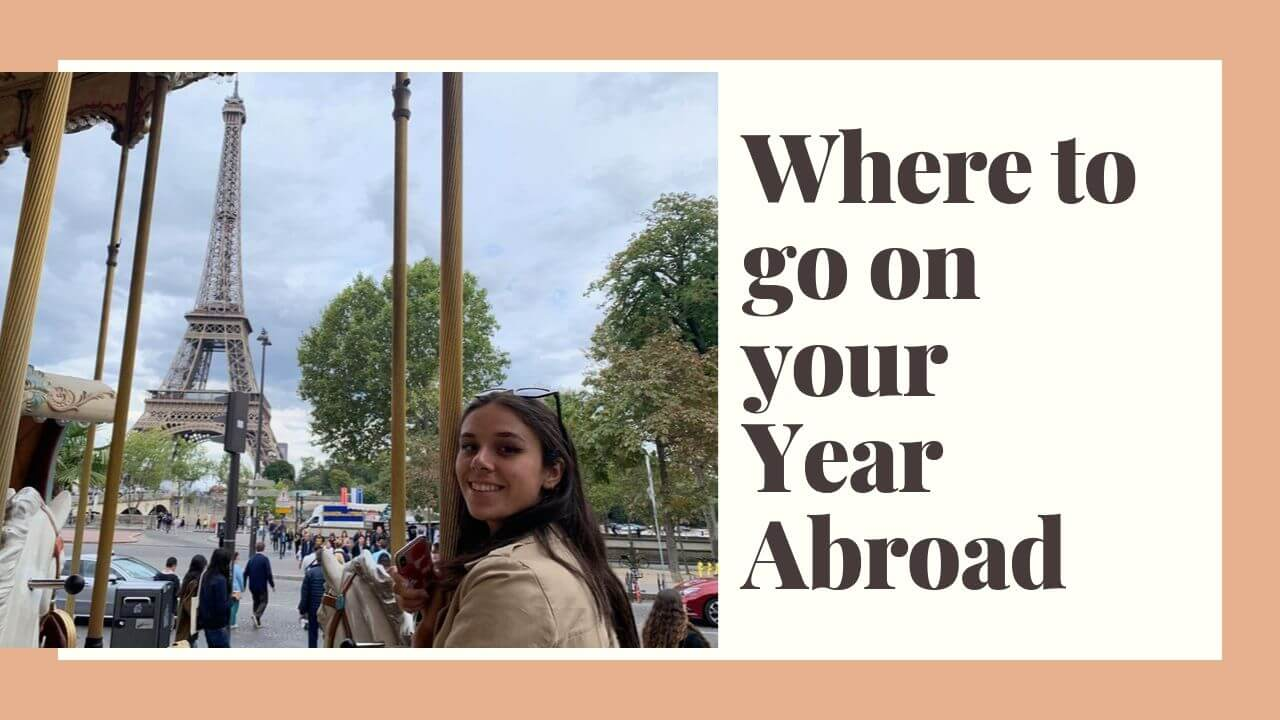Imagine a scenario where the person in the image has just received excellent news while on the carousel. What might the news be and how does it affect their day or trip? The woman receives a notification on her phone while on the carousel: she's been accepted into a prestigious internship program in Paris starting immediately after her year abroad. Ecstatic, her mind races with plans for the future. She starts to envision herself working in one of the chic Parisian offices, meeting professionals from around the world, and further immersing herself in the culture she's come to adore. Her day becomes even more thrilling, as each new sight and sound of Paris feels like a prelude to her next grand adventure. 